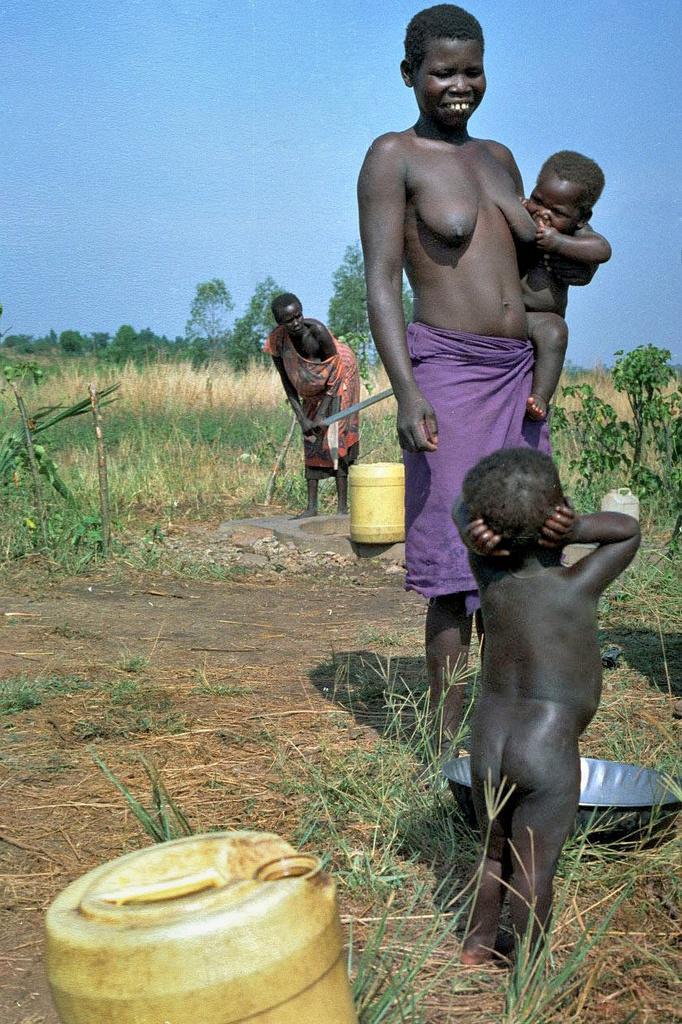In one or two sentences, can you explain what this image depicts? In the picture we can see some tribal people are standing on the path with their children and in the background, we can see the grass surface with grass plants and in the background we can see some trees and sky. 